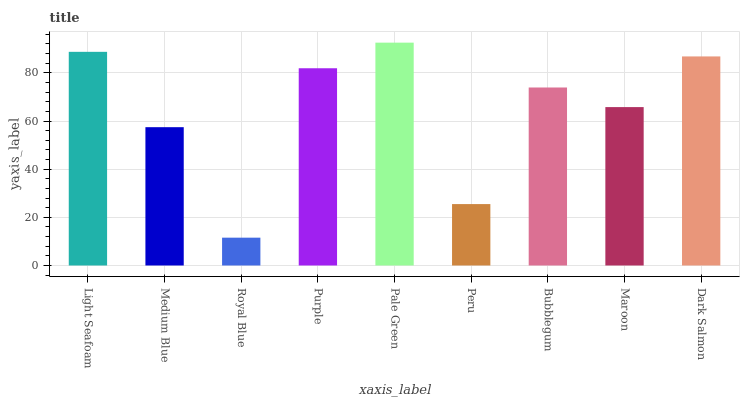Is Royal Blue the minimum?
Answer yes or no. Yes. Is Pale Green the maximum?
Answer yes or no. Yes. Is Medium Blue the minimum?
Answer yes or no. No. Is Medium Blue the maximum?
Answer yes or no. No. Is Light Seafoam greater than Medium Blue?
Answer yes or no. Yes. Is Medium Blue less than Light Seafoam?
Answer yes or no. Yes. Is Medium Blue greater than Light Seafoam?
Answer yes or no. No. Is Light Seafoam less than Medium Blue?
Answer yes or no. No. Is Bubblegum the high median?
Answer yes or no. Yes. Is Bubblegum the low median?
Answer yes or no. Yes. Is Light Seafoam the high median?
Answer yes or no. No. Is Medium Blue the low median?
Answer yes or no. No. 